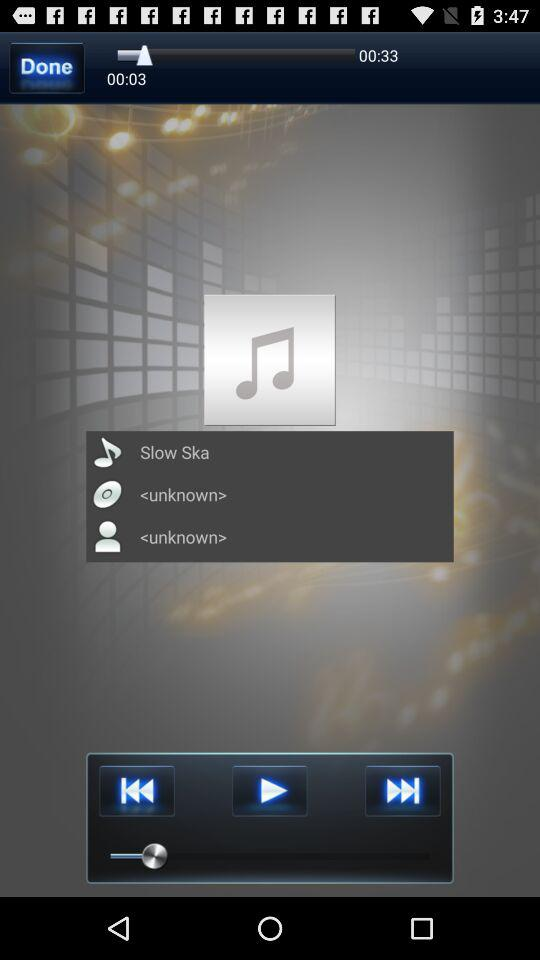What is the name of the song? The name of the song is "Slow Ska". 